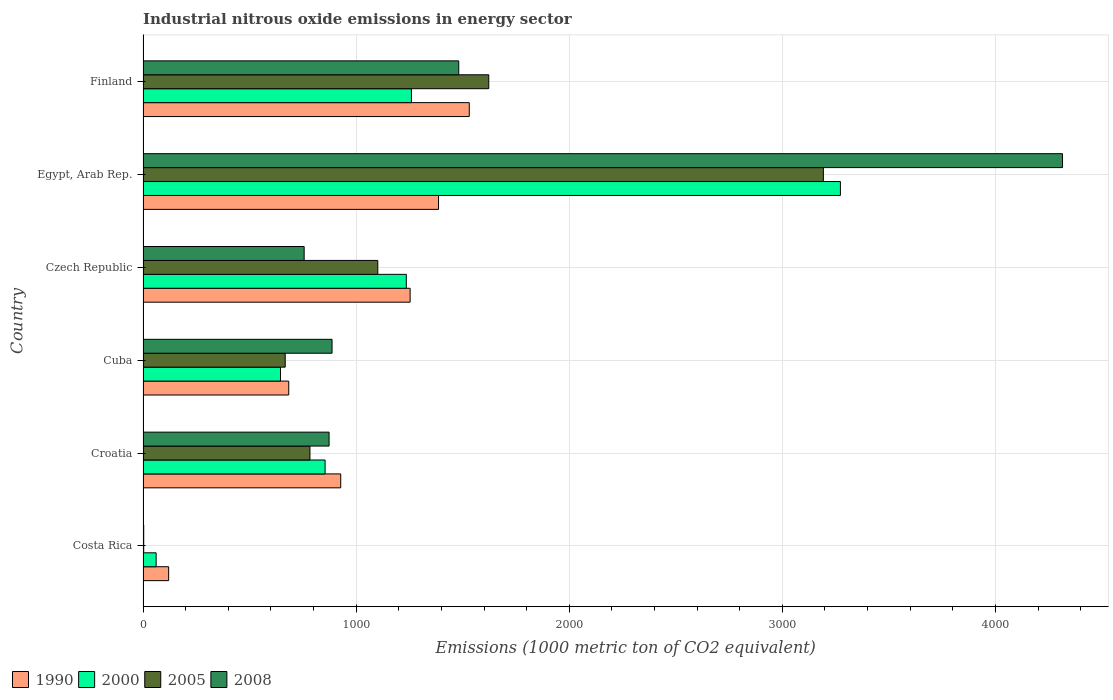Are the number of bars per tick equal to the number of legend labels?
Make the answer very short. Yes. How many bars are there on the 4th tick from the top?
Keep it short and to the point. 4. What is the label of the 3rd group of bars from the top?
Offer a terse response. Czech Republic. In how many cases, is the number of bars for a given country not equal to the number of legend labels?
Your answer should be compact. 0. What is the amount of industrial nitrous oxide emitted in 2005 in Cuba?
Your answer should be compact. 667.1. Across all countries, what is the maximum amount of industrial nitrous oxide emitted in 2008?
Ensure brevity in your answer.  4315. In which country was the amount of industrial nitrous oxide emitted in 2005 maximum?
Provide a succinct answer. Egypt, Arab Rep. In which country was the amount of industrial nitrous oxide emitted in 1990 minimum?
Make the answer very short. Costa Rica. What is the total amount of industrial nitrous oxide emitted in 2000 in the graph?
Offer a very short reply. 7328.2. What is the difference between the amount of industrial nitrous oxide emitted in 2008 in Costa Rica and that in Egypt, Arab Rep.?
Offer a terse response. -4311.9. What is the difference between the amount of industrial nitrous oxide emitted in 2008 in Czech Republic and the amount of industrial nitrous oxide emitted in 2005 in Finland?
Ensure brevity in your answer.  -866.4. What is the average amount of industrial nitrous oxide emitted in 2005 per country?
Ensure brevity in your answer.  1228.32. What is the difference between the amount of industrial nitrous oxide emitted in 2000 and amount of industrial nitrous oxide emitted in 1990 in Cuba?
Your response must be concise. -38.6. What is the ratio of the amount of industrial nitrous oxide emitted in 1990 in Czech Republic to that in Finland?
Offer a very short reply. 0.82. What is the difference between the highest and the second highest amount of industrial nitrous oxide emitted in 2000?
Your response must be concise. 2013.3. What is the difference between the highest and the lowest amount of industrial nitrous oxide emitted in 2008?
Keep it short and to the point. 4311.9. Is the sum of the amount of industrial nitrous oxide emitted in 2000 in Cuba and Finland greater than the maximum amount of industrial nitrous oxide emitted in 2005 across all countries?
Offer a very short reply. No. Is it the case that in every country, the sum of the amount of industrial nitrous oxide emitted in 1990 and amount of industrial nitrous oxide emitted in 2000 is greater than the sum of amount of industrial nitrous oxide emitted in 2005 and amount of industrial nitrous oxide emitted in 2008?
Make the answer very short. No. What does the 4th bar from the top in Finland represents?
Provide a short and direct response. 1990. How many bars are there?
Your answer should be very brief. 24. How many countries are there in the graph?
Make the answer very short. 6. What is the difference between two consecutive major ticks on the X-axis?
Provide a succinct answer. 1000. Are the values on the major ticks of X-axis written in scientific E-notation?
Offer a very short reply. No. Does the graph contain grids?
Keep it short and to the point. Yes. How are the legend labels stacked?
Make the answer very short. Horizontal. What is the title of the graph?
Offer a terse response. Industrial nitrous oxide emissions in energy sector. What is the label or title of the X-axis?
Offer a terse response. Emissions (1000 metric ton of CO2 equivalent). What is the label or title of the Y-axis?
Your answer should be very brief. Country. What is the Emissions (1000 metric ton of CO2 equivalent) of 1990 in Costa Rica?
Keep it short and to the point. 120. What is the Emissions (1000 metric ton of CO2 equivalent) in 2000 in Costa Rica?
Your response must be concise. 61.4. What is the Emissions (1000 metric ton of CO2 equivalent) of 1990 in Croatia?
Your answer should be very brief. 927.7. What is the Emissions (1000 metric ton of CO2 equivalent) in 2000 in Croatia?
Offer a terse response. 854.3. What is the Emissions (1000 metric ton of CO2 equivalent) in 2005 in Croatia?
Provide a succinct answer. 783.2. What is the Emissions (1000 metric ton of CO2 equivalent) in 2008 in Croatia?
Your response must be concise. 873. What is the Emissions (1000 metric ton of CO2 equivalent) in 1990 in Cuba?
Provide a short and direct response. 683.6. What is the Emissions (1000 metric ton of CO2 equivalent) in 2000 in Cuba?
Your response must be concise. 645. What is the Emissions (1000 metric ton of CO2 equivalent) of 2005 in Cuba?
Provide a succinct answer. 667.1. What is the Emissions (1000 metric ton of CO2 equivalent) of 2008 in Cuba?
Ensure brevity in your answer.  886.9. What is the Emissions (1000 metric ton of CO2 equivalent) of 1990 in Czech Republic?
Your answer should be very brief. 1253.3. What is the Emissions (1000 metric ton of CO2 equivalent) in 2000 in Czech Republic?
Give a very brief answer. 1235.4. What is the Emissions (1000 metric ton of CO2 equivalent) of 2005 in Czech Republic?
Your answer should be compact. 1101.5. What is the Emissions (1000 metric ton of CO2 equivalent) in 2008 in Czech Republic?
Provide a short and direct response. 756. What is the Emissions (1000 metric ton of CO2 equivalent) in 1990 in Egypt, Arab Rep.?
Provide a short and direct response. 1386.6. What is the Emissions (1000 metric ton of CO2 equivalent) in 2000 in Egypt, Arab Rep.?
Make the answer very short. 3272.7. What is the Emissions (1000 metric ton of CO2 equivalent) of 2005 in Egypt, Arab Rep.?
Your answer should be very brief. 3192.6. What is the Emissions (1000 metric ton of CO2 equivalent) of 2008 in Egypt, Arab Rep.?
Your answer should be compact. 4315. What is the Emissions (1000 metric ton of CO2 equivalent) in 1990 in Finland?
Your answer should be very brief. 1530.9. What is the Emissions (1000 metric ton of CO2 equivalent) in 2000 in Finland?
Provide a short and direct response. 1259.4. What is the Emissions (1000 metric ton of CO2 equivalent) in 2005 in Finland?
Provide a succinct answer. 1622.4. What is the Emissions (1000 metric ton of CO2 equivalent) in 2008 in Finland?
Offer a very short reply. 1481.5. Across all countries, what is the maximum Emissions (1000 metric ton of CO2 equivalent) of 1990?
Provide a short and direct response. 1530.9. Across all countries, what is the maximum Emissions (1000 metric ton of CO2 equivalent) in 2000?
Offer a very short reply. 3272.7. Across all countries, what is the maximum Emissions (1000 metric ton of CO2 equivalent) of 2005?
Your answer should be compact. 3192.6. Across all countries, what is the maximum Emissions (1000 metric ton of CO2 equivalent) in 2008?
Make the answer very short. 4315. Across all countries, what is the minimum Emissions (1000 metric ton of CO2 equivalent) in 1990?
Offer a terse response. 120. Across all countries, what is the minimum Emissions (1000 metric ton of CO2 equivalent) of 2000?
Provide a succinct answer. 61.4. Across all countries, what is the minimum Emissions (1000 metric ton of CO2 equivalent) in 2005?
Your response must be concise. 3.1. Across all countries, what is the minimum Emissions (1000 metric ton of CO2 equivalent) of 2008?
Offer a very short reply. 3.1. What is the total Emissions (1000 metric ton of CO2 equivalent) of 1990 in the graph?
Provide a short and direct response. 5902.1. What is the total Emissions (1000 metric ton of CO2 equivalent) of 2000 in the graph?
Keep it short and to the point. 7328.2. What is the total Emissions (1000 metric ton of CO2 equivalent) of 2005 in the graph?
Make the answer very short. 7369.9. What is the total Emissions (1000 metric ton of CO2 equivalent) of 2008 in the graph?
Your answer should be compact. 8315.5. What is the difference between the Emissions (1000 metric ton of CO2 equivalent) of 1990 in Costa Rica and that in Croatia?
Give a very brief answer. -807.7. What is the difference between the Emissions (1000 metric ton of CO2 equivalent) of 2000 in Costa Rica and that in Croatia?
Your answer should be very brief. -792.9. What is the difference between the Emissions (1000 metric ton of CO2 equivalent) in 2005 in Costa Rica and that in Croatia?
Your answer should be very brief. -780.1. What is the difference between the Emissions (1000 metric ton of CO2 equivalent) in 2008 in Costa Rica and that in Croatia?
Provide a succinct answer. -869.9. What is the difference between the Emissions (1000 metric ton of CO2 equivalent) in 1990 in Costa Rica and that in Cuba?
Your answer should be very brief. -563.6. What is the difference between the Emissions (1000 metric ton of CO2 equivalent) of 2000 in Costa Rica and that in Cuba?
Give a very brief answer. -583.6. What is the difference between the Emissions (1000 metric ton of CO2 equivalent) of 2005 in Costa Rica and that in Cuba?
Your response must be concise. -664. What is the difference between the Emissions (1000 metric ton of CO2 equivalent) of 2008 in Costa Rica and that in Cuba?
Keep it short and to the point. -883.8. What is the difference between the Emissions (1000 metric ton of CO2 equivalent) of 1990 in Costa Rica and that in Czech Republic?
Ensure brevity in your answer.  -1133.3. What is the difference between the Emissions (1000 metric ton of CO2 equivalent) in 2000 in Costa Rica and that in Czech Republic?
Your answer should be compact. -1174. What is the difference between the Emissions (1000 metric ton of CO2 equivalent) of 2005 in Costa Rica and that in Czech Republic?
Ensure brevity in your answer.  -1098.4. What is the difference between the Emissions (1000 metric ton of CO2 equivalent) in 2008 in Costa Rica and that in Czech Republic?
Give a very brief answer. -752.9. What is the difference between the Emissions (1000 metric ton of CO2 equivalent) of 1990 in Costa Rica and that in Egypt, Arab Rep.?
Give a very brief answer. -1266.6. What is the difference between the Emissions (1000 metric ton of CO2 equivalent) of 2000 in Costa Rica and that in Egypt, Arab Rep.?
Give a very brief answer. -3211.3. What is the difference between the Emissions (1000 metric ton of CO2 equivalent) of 2005 in Costa Rica and that in Egypt, Arab Rep.?
Give a very brief answer. -3189.5. What is the difference between the Emissions (1000 metric ton of CO2 equivalent) of 2008 in Costa Rica and that in Egypt, Arab Rep.?
Make the answer very short. -4311.9. What is the difference between the Emissions (1000 metric ton of CO2 equivalent) of 1990 in Costa Rica and that in Finland?
Offer a very short reply. -1410.9. What is the difference between the Emissions (1000 metric ton of CO2 equivalent) in 2000 in Costa Rica and that in Finland?
Give a very brief answer. -1198. What is the difference between the Emissions (1000 metric ton of CO2 equivalent) of 2005 in Costa Rica and that in Finland?
Offer a terse response. -1619.3. What is the difference between the Emissions (1000 metric ton of CO2 equivalent) of 2008 in Costa Rica and that in Finland?
Your response must be concise. -1478.4. What is the difference between the Emissions (1000 metric ton of CO2 equivalent) in 1990 in Croatia and that in Cuba?
Offer a terse response. 244.1. What is the difference between the Emissions (1000 metric ton of CO2 equivalent) of 2000 in Croatia and that in Cuba?
Offer a terse response. 209.3. What is the difference between the Emissions (1000 metric ton of CO2 equivalent) in 2005 in Croatia and that in Cuba?
Your response must be concise. 116.1. What is the difference between the Emissions (1000 metric ton of CO2 equivalent) of 2008 in Croatia and that in Cuba?
Make the answer very short. -13.9. What is the difference between the Emissions (1000 metric ton of CO2 equivalent) in 1990 in Croatia and that in Czech Republic?
Provide a succinct answer. -325.6. What is the difference between the Emissions (1000 metric ton of CO2 equivalent) of 2000 in Croatia and that in Czech Republic?
Provide a succinct answer. -381.1. What is the difference between the Emissions (1000 metric ton of CO2 equivalent) in 2005 in Croatia and that in Czech Republic?
Your answer should be compact. -318.3. What is the difference between the Emissions (1000 metric ton of CO2 equivalent) in 2008 in Croatia and that in Czech Republic?
Provide a succinct answer. 117. What is the difference between the Emissions (1000 metric ton of CO2 equivalent) of 1990 in Croatia and that in Egypt, Arab Rep.?
Offer a terse response. -458.9. What is the difference between the Emissions (1000 metric ton of CO2 equivalent) of 2000 in Croatia and that in Egypt, Arab Rep.?
Make the answer very short. -2418.4. What is the difference between the Emissions (1000 metric ton of CO2 equivalent) of 2005 in Croatia and that in Egypt, Arab Rep.?
Your answer should be compact. -2409.4. What is the difference between the Emissions (1000 metric ton of CO2 equivalent) in 2008 in Croatia and that in Egypt, Arab Rep.?
Your answer should be very brief. -3442. What is the difference between the Emissions (1000 metric ton of CO2 equivalent) in 1990 in Croatia and that in Finland?
Offer a terse response. -603.2. What is the difference between the Emissions (1000 metric ton of CO2 equivalent) in 2000 in Croatia and that in Finland?
Offer a terse response. -405.1. What is the difference between the Emissions (1000 metric ton of CO2 equivalent) of 2005 in Croatia and that in Finland?
Your response must be concise. -839.2. What is the difference between the Emissions (1000 metric ton of CO2 equivalent) of 2008 in Croatia and that in Finland?
Provide a short and direct response. -608.5. What is the difference between the Emissions (1000 metric ton of CO2 equivalent) in 1990 in Cuba and that in Czech Republic?
Your answer should be compact. -569.7. What is the difference between the Emissions (1000 metric ton of CO2 equivalent) in 2000 in Cuba and that in Czech Republic?
Your answer should be very brief. -590.4. What is the difference between the Emissions (1000 metric ton of CO2 equivalent) of 2005 in Cuba and that in Czech Republic?
Keep it short and to the point. -434.4. What is the difference between the Emissions (1000 metric ton of CO2 equivalent) in 2008 in Cuba and that in Czech Republic?
Offer a terse response. 130.9. What is the difference between the Emissions (1000 metric ton of CO2 equivalent) of 1990 in Cuba and that in Egypt, Arab Rep.?
Provide a succinct answer. -703. What is the difference between the Emissions (1000 metric ton of CO2 equivalent) of 2000 in Cuba and that in Egypt, Arab Rep.?
Offer a very short reply. -2627.7. What is the difference between the Emissions (1000 metric ton of CO2 equivalent) in 2005 in Cuba and that in Egypt, Arab Rep.?
Offer a very short reply. -2525.5. What is the difference between the Emissions (1000 metric ton of CO2 equivalent) in 2008 in Cuba and that in Egypt, Arab Rep.?
Give a very brief answer. -3428.1. What is the difference between the Emissions (1000 metric ton of CO2 equivalent) in 1990 in Cuba and that in Finland?
Provide a succinct answer. -847.3. What is the difference between the Emissions (1000 metric ton of CO2 equivalent) of 2000 in Cuba and that in Finland?
Ensure brevity in your answer.  -614.4. What is the difference between the Emissions (1000 metric ton of CO2 equivalent) of 2005 in Cuba and that in Finland?
Provide a short and direct response. -955.3. What is the difference between the Emissions (1000 metric ton of CO2 equivalent) of 2008 in Cuba and that in Finland?
Give a very brief answer. -594.6. What is the difference between the Emissions (1000 metric ton of CO2 equivalent) of 1990 in Czech Republic and that in Egypt, Arab Rep.?
Keep it short and to the point. -133.3. What is the difference between the Emissions (1000 metric ton of CO2 equivalent) of 2000 in Czech Republic and that in Egypt, Arab Rep.?
Offer a terse response. -2037.3. What is the difference between the Emissions (1000 metric ton of CO2 equivalent) of 2005 in Czech Republic and that in Egypt, Arab Rep.?
Offer a terse response. -2091.1. What is the difference between the Emissions (1000 metric ton of CO2 equivalent) in 2008 in Czech Republic and that in Egypt, Arab Rep.?
Your answer should be compact. -3559. What is the difference between the Emissions (1000 metric ton of CO2 equivalent) in 1990 in Czech Republic and that in Finland?
Provide a succinct answer. -277.6. What is the difference between the Emissions (1000 metric ton of CO2 equivalent) of 2005 in Czech Republic and that in Finland?
Offer a terse response. -520.9. What is the difference between the Emissions (1000 metric ton of CO2 equivalent) in 2008 in Czech Republic and that in Finland?
Provide a succinct answer. -725.5. What is the difference between the Emissions (1000 metric ton of CO2 equivalent) of 1990 in Egypt, Arab Rep. and that in Finland?
Offer a terse response. -144.3. What is the difference between the Emissions (1000 metric ton of CO2 equivalent) in 2000 in Egypt, Arab Rep. and that in Finland?
Provide a succinct answer. 2013.3. What is the difference between the Emissions (1000 metric ton of CO2 equivalent) of 2005 in Egypt, Arab Rep. and that in Finland?
Ensure brevity in your answer.  1570.2. What is the difference between the Emissions (1000 metric ton of CO2 equivalent) of 2008 in Egypt, Arab Rep. and that in Finland?
Give a very brief answer. 2833.5. What is the difference between the Emissions (1000 metric ton of CO2 equivalent) of 1990 in Costa Rica and the Emissions (1000 metric ton of CO2 equivalent) of 2000 in Croatia?
Keep it short and to the point. -734.3. What is the difference between the Emissions (1000 metric ton of CO2 equivalent) of 1990 in Costa Rica and the Emissions (1000 metric ton of CO2 equivalent) of 2005 in Croatia?
Keep it short and to the point. -663.2. What is the difference between the Emissions (1000 metric ton of CO2 equivalent) of 1990 in Costa Rica and the Emissions (1000 metric ton of CO2 equivalent) of 2008 in Croatia?
Offer a very short reply. -753. What is the difference between the Emissions (1000 metric ton of CO2 equivalent) of 2000 in Costa Rica and the Emissions (1000 metric ton of CO2 equivalent) of 2005 in Croatia?
Your answer should be compact. -721.8. What is the difference between the Emissions (1000 metric ton of CO2 equivalent) of 2000 in Costa Rica and the Emissions (1000 metric ton of CO2 equivalent) of 2008 in Croatia?
Provide a succinct answer. -811.6. What is the difference between the Emissions (1000 metric ton of CO2 equivalent) of 2005 in Costa Rica and the Emissions (1000 metric ton of CO2 equivalent) of 2008 in Croatia?
Provide a succinct answer. -869.9. What is the difference between the Emissions (1000 metric ton of CO2 equivalent) of 1990 in Costa Rica and the Emissions (1000 metric ton of CO2 equivalent) of 2000 in Cuba?
Provide a succinct answer. -525. What is the difference between the Emissions (1000 metric ton of CO2 equivalent) of 1990 in Costa Rica and the Emissions (1000 metric ton of CO2 equivalent) of 2005 in Cuba?
Offer a very short reply. -547.1. What is the difference between the Emissions (1000 metric ton of CO2 equivalent) in 1990 in Costa Rica and the Emissions (1000 metric ton of CO2 equivalent) in 2008 in Cuba?
Provide a succinct answer. -766.9. What is the difference between the Emissions (1000 metric ton of CO2 equivalent) of 2000 in Costa Rica and the Emissions (1000 metric ton of CO2 equivalent) of 2005 in Cuba?
Provide a succinct answer. -605.7. What is the difference between the Emissions (1000 metric ton of CO2 equivalent) of 2000 in Costa Rica and the Emissions (1000 metric ton of CO2 equivalent) of 2008 in Cuba?
Provide a succinct answer. -825.5. What is the difference between the Emissions (1000 metric ton of CO2 equivalent) of 2005 in Costa Rica and the Emissions (1000 metric ton of CO2 equivalent) of 2008 in Cuba?
Ensure brevity in your answer.  -883.8. What is the difference between the Emissions (1000 metric ton of CO2 equivalent) of 1990 in Costa Rica and the Emissions (1000 metric ton of CO2 equivalent) of 2000 in Czech Republic?
Provide a short and direct response. -1115.4. What is the difference between the Emissions (1000 metric ton of CO2 equivalent) in 1990 in Costa Rica and the Emissions (1000 metric ton of CO2 equivalent) in 2005 in Czech Republic?
Your answer should be very brief. -981.5. What is the difference between the Emissions (1000 metric ton of CO2 equivalent) in 1990 in Costa Rica and the Emissions (1000 metric ton of CO2 equivalent) in 2008 in Czech Republic?
Make the answer very short. -636. What is the difference between the Emissions (1000 metric ton of CO2 equivalent) in 2000 in Costa Rica and the Emissions (1000 metric ton of CO2 equivalent) in 2005 in Czech Republic?
Make the answer very short. -1040.1. What is the difference between the Emissions (1000 metric ton of CO2 equivalent) of 2000 in Costa Rica and the Emissions (1000 metric ton of CO2 equivalent) of 2008 in Czech Republic?
Your answer should be very brief. -694.6. What is the difference between the Emissions (1000 metric ton of CO2 equivalent) of 2005 in Costa Rica and the Emissions (1000 metric ton of CO2 equivalent) of 2008 in Czech Republic?
Provide a succinct answer. -752.9. What is the difference between the Emissions (1000 metric ton of CO2 equivalent) in 1990 in Costa Rica and the Emissions (1000 metric ton of CO2 equivalent) in 2000 in Egypt, Arab Rep.?
Give a very brief answer. -3152.7. What is the difference between the Emissions (1000 metric ton of CO2 equivalent) in 1990 in Costa Rica and the Emissions (1000 metric ton of CO2 equivalent) in 2005 in Egypt, Arab Rep.?
Your response must be concise. -3072.6. What is the difference between the Emissions (1000 metric ton of CO2 equivalent) of 1990 in Costa Rica and the Emissions (1000 metric ton of CO2 equivalent) of 2008 in Egypt, Arab Rep.?
Offer a very short reply. -4195. What is the difference between the Emissions (1000 metric ton of CO2 equivalent) of 2000 in Costa Rica and the Emissions (1000 metric ton of CO2 equivalent) of 2005 in Egypt, Arab Rep.?
Give a very brief answer. -3131.2. What is the difference between the Emissions (1000 metric ton of CO2 equivalent) in 2000 in Costa Rica and the Emissions (1000 metric ton of CO2 equivalent) in 2008 in Egypt, Arab Rep.?
Offer a terse response. -4253.6. What is the difference between the Emissions (1000 metric ton of CO2 equivalent) in 2005 in Costa Rica and the Emissions (1000 metric ton of CO2 equivalent) in 2008 in Egypt, Arab Rep.?
Offer a very short reply. -4311.9. What is the difference between the Emissions (1000 metric ton of CO2 equivalent) in 1990 in Costa Rica and the Emissions (1000 metric ton of CO2 equivalent) in 2000 in Finland?
Make the answer very short. -1139.4. What is the difference between the Emissions (1000 metric ton of CO2 equivalent) of 1990 in Costa Rica and the Emissions (1000 metric ton of CO2 equivalent) of 2005 in Finland?
Your response must be concise. -1502.4. What is the difference between the Emissions (1000 metric ton of CO2 equivalent) of 1990 in Costa Rica and the Emissions (1000 metric ton of CO2 equivalent) of 2008 in Finland?
Provide a succinct answer. -1361.5. What is the difference between the Emissions (1000 metric ton of CO2 equivalent) of 2000 in Costa Rica and the Emissions (1000 metric ton of CO2 equivalent) of 2005 in Finland?
Provide a succinct answer. -1561. What is the difference between the Emissions (1000 metric ton of CO2 equivalent) in 2000 in Costa Rica and the Emissions (1000 metric ton of CO2 equivalent) in 2008 in Finland?
Offer a very short reply. -1420.1. What is the difference between the Emissions (1000 metric ton of CO2 equivalent) of 2005 in Costa Rica and the Emissions (1000 metric ton of CO2 equivalent) of 2008 in Finland?
Your answer should be compact. -1478.4. What is the difference between the Emissions (1000 metric ton of CO2 equivalent) of 1990 in Croatia and the Emissions (1000 metric ton of CO2 equivalent) of 2000 in Cuba?
Offer a terse response. 282.7. What is the difference between the Emissions (1000 metric ton of CO2 equivalent) of 1990 in Croatia and the Emissions (1000 metric ton of CO2 equivalent) of 2005 in Cuba?
Your answer should be very brief. 260.6. What is the difference between the Emissions (1000 metric ton of CO2 equivalent) in 1990 in Croatia and the Emissions (1000 metric ton of CO2 equivalent) in 2008 in Cuba?
Your answer should be compact. 40.8. What is the difference between the Emissions (1000 metric ton of CO2 equivalent) in 2000 in Croatia and the Emissions (1000 metric ton of CO2 equivalent) in 2005 in Cuba?
Provide a succinct answer. 187.2. What is the difference between the Emissions (1000 metric ton of CO2 equivalent) in 2000 in Croatia and the Emissions (1000 metric ton of CO2 equivalent) in 2008 in Cuba?
Offer a very short reply. -32.6. What is the difference between the Emissions (1000 metric ton of CO2 equivalent) in 2005 in Croatia and the Emissions (1000 metric ton of CO2 equivalent) in 2008 in Cuba?
Make the answer very short. -103.7. What is the difference between the Emissions (1000 metric ton of CO2 equivalent) in 1990 in Croatia and the Emissions (1000 metric ton of CO2 equivalent) in 2000 in Czech Republic?
Provide a short and direct response. -307.7. What is the difference between the Emissions (1000 metric ton of CO2 equivalent) of 1990 in Croatia and the Emissions (1000 metric ton of CO2 equivalent) of 2005 in Czech Republic?
Ensure brevity in your answer.  -173.8. What is the difference between the Emissions (1000 metric ton of CO2 equivalent) of 1990 in Croatia and the Emissions (1000 metric ton of CO2 equivalent) of 2008 in Czech Republic?
Provide a succinct answer. 171.7. What is the difference between the Emissions (1000 metric ton of CO2 equivalent) of 2000 in Croatia and the Emissions (1000 metric ton of CO2 equivalent) of 2005 in Czech Republic?
Keep it short and to the point. -247.2. What is the difference between the Emissions (1000 metric ton of CO2 equivalent) of 2000 in Croatia and the Emissions (1000 metric ton of CO2 equivalent) of 2008 in Czech Republic?
Ensure brevity in your answer.  98.3. What is the difference between the Emissions (1000 metric ton of CO2 equivalent) in 2005 in Croatia and the Emissions (1000 metric ton of CO2 equivalent) in 2008 in Czech Republic?
Your answer should be very brief. 27.2. What is the difference between the Emissions (1000 metric ton of CO2 equivalent) of 1990 in Croatia and the Emissions (1000 metric ton of CO2 equivalent) of 2000 in Egypt, Arab Rep.?
Offer a terse response. -2345. What is the difference between the Emissions (1000 metric ton of CO2 equivalent) of 1990 in Croatia and the Emissions (1000 metric ton of CO2 equivalent) of 2005 in Egypt, Arab Rep.?
Give a very brief answer. -2264.9. What is the difference between the Emissions (1000 metric ton of CO2 equivalent) in 1990 in Croatia and the Emissions (1000 metric ton of CO2 equivalent) in 2008 in Egypt, Arab Rep.?
Ensure brevity in your answer.  -3387.3. What is the difference between the Emissions (1000 metric ton of CO2 equivalent) of 2000 in Croatia and the Emissions (1000 metric ton of CO2 equivalent) of 2005 in Egypt, Arab Rep.?
Give a very brief answer. -2338.3. What is the difference between the Emissions (1000 metric ton of CO2 equivalent) in 2000 in Croatia and the Emissions (1000 metric ton of CO2 equivalent) in 2008 in Egypt, Arab Rep.?
Your answer should be compact. -3460.7. What is the difference between the Emissions (1000 metric ton of CO2 equivalent) in 2005 in Croatia and the Emissions (1000 metric ton of CO2 equivalent) in 2008 in Egypt, Arab Rep.?
Your answer should be very brief. -3531.8. What is the difference between the Emissions (1000 metric ton of CO2 equivalent) of 1990 in Croatia and the Emissions (1000 metric ton of CO2 equivalent) of 2000 in Finland?
Your answer should be very brief. -331.7. What is the difference between the Emissions (1000 metric ton of CO2 equivalent) in 1990 in Croatia and the Emissions (1000 metric ton of CO2 equivalent) in 2005 in Finland?
Make the answer very short. -694.7. What is the difference between the Emissions (1000 metric ton of CO2 equivalent) in 1990 in Croatia and the Emissions (1000 metric ton of CO2 equivalent) in 2008 in Finland?
Your answer should be very brief. -553.8. What is the difference between the Emissions (1000 metric ton of CO2 equivalent) of 2000 in Croatia and the Emissions (1000 metric ton of CO2 equivalent) of 2005 in Finland?
Your answer should be very brief. -768.1. What is the difference between the Emissions (1000 metric ton of CO2 equivalent) of 2000 in Croatia and the Emissions (1000 metric ton of CO2 equivalent) of 2008 in Finland?
Make the answer very short. -627.2. What is the difference between the Emissions (1000 metric ton of CO2 equivalent) of 2005 in Croatia and the Emissions (1000 metric ton of CO2 equivalent) of 2008 in Finland?
Keep it short and to the point. -698.3. What is the difference between the Emissions (1000 metric ton of CO2 equivalent) of 1990 in Cuba and the Emissions (1000 metric ton of CO2 equivalent) of 2000 in Czech Republic?
Make the answer very short. -551.8. What is the difference between the Emissions (1000 metric ton of CO2 equivalent) of 1990 in Cuba and the Emissions (1000 metric ton of CO2 equivalent) of 2005 in Czech Republic?
Your response must be concise. -417.9. What is the difference between the Emissions (1000 metric ton of CO2 equivalent) in 1990 in Cuba and the Emissions (1000 metric ton of CO2 equivalent) in 2008 in Czech Republic?
Offer a very short reply. -72.4. What is the difference between the Emissions (1000 metric ton of CO2 equivalent) of 2000 in Cuba and the Emissions (1000 metric ton of CO2 equivalent) of 2005 in Czech Republic?
Provide a succinct answer. -456.5. What is the difference between the Emissions (1000 metric ton of CO2 equivalent) of 2000 in Cuba and the Emissions (1000 metric ton of CO2 equivalent) of 2008 in Czech Republic?
Your answer should be very brief. -111. What is the difference between the Emissions (1000 metric ton of CO2 equivalent) in 2005 in Cuba and the Emissions (1000 metric ton of CO2 equivalent) in 2008 in Czech Republic?
Offer a terse response. -88.9. What is the difference between the Emissions (1000 metric ton of CO2 equivalent) of 1990 in Cuba and the Emissions (1000 metric ton of CO2 equivalent) of 2000 in Egypt, Arab Rep.?
Your answer should be compact. -2589.1. What is the difference between the Emissions (1000 metric ton of CO2 equivalent) of 1990 in Cuba and the Emissions (1000 metric ton of CO2 equivalent) of 2005 in Egypt, Arab Rep.?
Keep it short and to the point. -2509. What is the difference between the Emissions (1000 metric ton of CO2 equivalent) of 1990 in Cuba and the Emissions (1000 metric ton of CO2 equivalent) of 2008 in Egypt, Arab Rep.?
Your answer should be compact. -3631.4. What is the difference between the Emissions (1000 metric ton of CO2 equivalent) of 2000 in Cuba and the Emissions (1000 metric ton of CO2 equivalent) of 2005 in Egypt, Arab Rep.?
Make the answer very short. -2547.6. What is the difference between the Emissions (1000 metric ton of CO2 equivalent) of 2000 in Cuba and the Emissions (1000 metric ton of CO2 equivalent) of 2008 in Egypt, Arab Rep.?
Keep it short and to the point. -3670. What is the difference between the Emissions (1000 metric ton of CO2 equivalent) of 2005 in Cuba and the Emissions (1000 metric ton of CO2 equivalent) of 2008 in Egypt, Arab Rep.?
Provide a succinct answer. -3647.9. What is the difference between the Emissions (1000 metric ton of CO2 equivalent) in 1990 in Cuba and the Emissions (1000 metric ton of CO2 equivalent) in 2000 in Finland?
Your answer should be very brief. -575.8. What is the difference between the Emissions (1000 metric ton of CO2 equivalent) of 1990 in Cuba and the Emissions (1000 metric ton of CO2 equivalent) of 2005 in Finland?
Give a very brief answer. -938.8. What is the difference between the Emissions (1000 metric ton of CO2 equivalent) in 1990 in Cuba and the Emissions (1000 metric ton of CO2 equivalent) in 2008 in Finland?
Ensure brevity in your answer.  -797.9. What is the difference between the Emissions (1000 metric ton of CO2 equivalent) in 2000 in Cuba and the Emissions (1000 metric ton of CO2 equivalent) in 2005 in Finland?
Make the answer very short. -977.4. What is the difference between the Emissions (1000 metric ton of CO2 equivalent) in 2000 in Cuba and the Emissions (1000 metric ton of CO2 equivalent) in 2008 in Finland?
Keep it short and to the point. -836.5. What is the difference between the Emissions (1000 metric ton of CO2 equivalent) of 2005 in Cuba and the Emissions (1000 metric ton of CO2 equivalent) of 2008 in Finland?
Your answer should be very brief. -814.4. What is the difference between the Emissions (1000 metric ton of CO2 equivalent) in 1990 in Czech Republic and the Emissions (1000 metric ton of CO2 equivalent) in 2000 in Egypt, Arab Rep.?
Offer a very short reply. -2019.4. What is the difference between the Emissions (1000 metric ton of CO2 equivalent) of 1990 in Czech Republic and the Emissions (1000 metric ton of CO2 equivalent) of 2005 in Egypt, Arab Rep.?
Ensure brevity in your answer.  -1939.3. What is the difference between the Emissions (1000 metric ton of CO2 equivalent) of 1990 in Czech Republic and the Emissions (1000 metric ton of CO2 equivalent) of 2008 in Egypt, Arab Rep.?
Your response must be concise. -3061.7. What is the difference between the Emissions (1000 metric ton of CO2 equivalent) of 2000 in Czech Republic and the Emissions (1000 metric ton of CO2 equivalent) of 2005 in Egypt, Arab Rep.?
Your response must be concise. -1957.2. What is the difference between the Emissions (1000 metric ton of CO2 equivalent) of 2000 in Czech Republic and the Emissions (1000 metric ton of CO2 equivalent) of 2008 in Egypt, Arab Rep.?
Your response must be concise. -3079.6. What is the difference between the Emissions (1000 metric ton of CO2 equivalent) in 2005 in Czech Republic and the Emissions (1000 metric ton of CO2 equivalent) in 2008 in Egypt, Arab Rep.?
Your answer should be very brief. -3213.5. What is the difference between the Emissions (1000 metric ton of CO2 equivalent) in 1990 in Czech Republic and the Emissions (1000 metric ton of CO2 equivalent) in 2005 in Finland?
Your answer should be compact. -369.1. What is the difference between the Emissions (1000 metric ton of CO2 equivalent) of 1990 in Czech Republic and the Emissions (1000 metric ton of CO2 equivalent) of 2008 in Finland?
Make the answer very short. -228.2. What is the difference between the Emissions (1000 metric ton of CO2 equivalent) in 2000 in Czech Republic and the Emissions (1000 metric ton of CO2 equivalent) in 2005 in Finland?
Make the answer very short. -387. What is the difference between the Emissions (1000 metric ton of CO2 equivalent) in 2000 in Czech Republic and the Emissions (1000 metric ton of CO2 equivalent) in 2008 in Finland?
Provide a short and direct response. -246.1. What is the difference between the Emissions (1000 metric ton of CO2 equivalent) in 2005 in Czech Republic and the Emissions (1000 metric ton of CO2 equivalent) in 2008 in Finland?
Keep it short and to the point. -380. What is the difference between the Emissions (1000 metric ton of CO2 equivalent) of 1990 in Egypt, Arab Rep. and the Emissions (1000 metric ton of CO2 equivalent) of 2000 in Finland?
Offer a very short reply. 127.2. What is the difference between the Emissions (1000 metric ton of CO2 equivalent) of 1990 in Egypt, Arab Rep. and the Emissions (1000 metric ton of CO2 equivalent) of 2005 in Finland?
Offer a very short reply. -235.8. What is the difference between the Emissions (1000 metric ton of CO2 equivalent) of 1990 in Egypt, Arab Rep. and the Emissions (1000 metric ton of CO2 equivalent) of 2008 in Finland?
Offer a very short reply. -94.9. What is the difference between the Emissions (1000 metric ton of CO2 equivalent) of 2000 in Egypt, Arab Rep. and the Emissions (1000 metric ton of CO2 equivalent) of 2005 in Finland?
Ensure brevity in your answer.  1650.3. What is the difference between the Emissions (1000 metric ton of CO2 equivalent) in 2000 in Egypt, Arab Rep. and the Emissions (1000 metric ton of CO2 equivalent) in 2008 in Finland?
Keep it short and to the point. 1791.2. What is the difference between the Emissions (1000 metric ton of CO2 equivalent) of 2005 in Egypt, Arab Rep. and the Emissions (1000 metric ton of CO2 equivalent) of 2008 in Finland?
Your answer should be compact. 1711.1. What is the average Emissions (1000 metric ton of CO2 equivalent) of 1990 per country?
Provide a succinct answer. 983.68. What is the average Emissions (1000 metric ton of CO2 equivalent) in 2000 per country?
Offer a terse response. 1221.37. What is the average Emissions (1000 metric ton of CO2 equivalent) in 2005 per country?
Your answer should be very brief. 1228.32. What is the average Emissions (1000 metric ton of CO2 equivalent) of 2008 per country?
Provide a short and direct response. 1385.92. What is the difference between the Emissions (1000 metric ton of CO2 equivalent) of 1990 and Emissions (1000 metric ton of CO2 equivalent) of 2000 in Costa Rica?
Ensure brevity in your answer.  58.6. What is the difference between the Emissions (1000 metric ton of CO2 equivalent) of 1990 and Emissions (1000 metric ton of CO2 equivalent) of 2005 in Costa Rica?
Ensure brevity in your answer.  116.9. What is the difference between the Emissions (1000 metric ton of CO2 equivalent) in 1990 and Emissions (1000 metric ton of CO2 equivalent) in 2008 in Costa Rica?
Your response must be concise. 116.9. What is the difference between the Emissions (1000 metric ton of CO2 equivalent) of 2000 and Emissions (1000 metric ton of CO2 equivalent) of 2005 in Costa Rica?
Your response must be concise. 58.3. What is the difference between the Emissions (1000 metric ton of CO2 equivalent) of 2000 and Emissions (1000 metric ton of CO2 equivalent) of 2008 in Costa Rica?
Your answer should be very brief. 58.3. What is the difference between the Emissions (1000 metric ton of CO2 equivalent) in 2005 and Emissions (1000 metric ton of CO2 equivalent) in 2008 in Costa Rica?
Your answer should be very brief. 0. What is the difference between the Emissions (1000 metric ton of CO2 equivalent) of 1990 and Emissions (1000 metric ton of CO2 equivalent) of 2000 in Croatia?
Provide a succinct answer. 73.4. What is the difference between the Emissions (1000 metric ton of CO2 equivalent) in 1990 and Emissions (1000 metric ton of CO2 equivalent) in 2005 in Croatia?
Provide a short and direct response. 144.5. What is the difference between the Emissions (1000 metric ton of CO2 equivalent) of 1990 and Emissions (1000 metric ton of CO2 equivalent) of 2008 in Croatia?
Offer a very short reply. 54.7. What is the difference between the Emissions (1000 metric ton of CO2 equivalent) of 2000 and Emissions (1000 metric ton of CO2 equivalent) of 2005 in Croatia?
Your response must be concise. 71.1. What is the difference between the Emissions (1000 metric ton of CO2 equivalent) of 2000 and Emissions (1000 metric ton of CO2 equivalent) of 2008 in Croatia?
Provide a succinct answer. -18.7. What is the difference between the Emissions (1000 metric ton of CO2 equivalent) of 2005 and Emissions (1000 metric ton of CO2 equivalent) of 2008 in Croatia?
Your answer should be compact. -89.8. What is the difference between the Emissions (1000 metric ton of CO2 equivalent) in 1990 and Emissions (1000 metric ton of CO2 equivalent) in 2000 in Cuba?
Give a very brief answer. 38.6. What is the difference between the Emissions (1000 metric ton of CO2 equivalent) of 1990 and Emissions (1000 metric ton of CO2 equivalent) of 2005 in Cuba?
Give a very brief answer. 16.5. What is the difference between the Emissions (1000 metric ton of CO2 equivalent) in 1990 and Emissions (1000 metric ton of CO2 equivalent) in 2008 in Cuba?
Ensure brevity in your answer.  -203.3. What is the difference between the Emissions (1000 metric ton of CO2 equivalent) in 2000 and Emissions (1000 metric ton of CO2 equivalent) in 2005 in Cuba?
Make the answer very short. -22.1. What is the difference between the Emissions (1000 metric ton of CO2 equivalent) in 2000 and Emissions (1000 metric ton of CO2 equivalent) in 2008 in Cuba?
Provide a succinct answer. -241.9. What is the difference between the Emissions (1000 metric ton of CO2 equivalent) in 2005 and Emissions (1000 metric ton of CO2 equivalent) in 2008 in Cuba?
Offer a terse response. -219.8. What is the difference between the Emissions (1000 metric ton of CO2 equivalent) in 1990 and Emissions (1000 metric ton of CO2 equivalent) in 2000 in Czech Republic?
Ensure brevity in your answer.  17.9. What is the difference between the Emissions (1000 metric ton of CO2 equivalent) of 1990 and Emissions (1000 metric ton of CO2 equivalent) of 2005 in Czech Republic?
Provide a short and direct response. 151.8. What is the difference between the Emissions (1000 metric ton of CO2 equivalent) in 1990 and Emissions (1000 metric ton of CO2 equivalent) in 2008 in Czech Republic?
Give a very brief answer. 497.3. What is the difference between the Emissions (1000 metric ton of CO2 equivalent) of 2000 and Emissions (1000 metric ton of CO2 equivalent) of 2005 in Czech Republic?
Keep it short and to the point. 133.9. What is the difference between the Emissions (1000 metric ton of CO2 equivalent) of 2000 and Emissions (1000 metric ton of CO2 equivalent) of 2008 in Czech Republic?
Provide a succinct answer. 479.4. What is the difference between the Emissions (1000 metric ton of CO2 equivalent) of 2005 and Emissions (1000 metric ton of CO2 equivalent) of 2008 in Czech Republic?
Give a very brief answer. 345.5. What is the difference between the Emissions (1000 metric ton of CO2 equivalent) of 1990 and Emissions (1000 metric ton of CO2 equivalent) of 2000 in Egypt, Arab Rep.?
Offer a very short reply. -1886.1. What is the difference between the Emissions (1000 metric ton of CO2 equivalent) of 1990 and Emissions (1000 metric ton of CO2 equivalent) of 2005 in Egypt, Arab Rep.?
Give a very brief answer. -1806. What is the difference between the Emissions (1000 metric ton of CO2 equivalent) of 1990 and Emissions (1000 metric ton of CO2 equivalent) of 2008 in Egypt, Arab Rep.?
Your answer should be very brief. -2928.4. What is the difference between the Emissions (1000 metric ton of CO2 equivalent) of 2000 and Emissions (1000 metric ton of CO2 equivalent) of 2005 in Egypt, Arab Rep.?
Provide a short and direct response. 80.1. What is the difference between the Emissions (1000 metric ton of CO2 equivalent) in 2000 and Emissions (1000 metric ton of CO2 equivalent) in 2008 in Egypt, Arab Rep.?
Provide a short and direct response. -1042.3. What is the difference between the Emissions (1000 metric ton of CO2 equivalent) in 2005 and Emissions (1000 metric ton of CO2 equivalent) in 2008 in Egypt, Arab Rep.?
Keep it short and to the point. -1122.4. What is the difference between the Emissions (1000 metric ton of CO2 equivalent) of 1990 and Emissions (1000 metric ton of CO2 equivalent) of 2000 in Finland?
Your answer should be compact. 271.5. What is the difference between the Emissions (1000 metric ton of CO2 equivalent) in 1990 and Emissions (1000 metric ton of CO2 equivalent) in 2005 in Finland?
Offer a very short reply. -91.5. What is the difference between the Emissions (1000 metric ton of CO2 equivalent) of 1990 and Emissions (1000 metric ton of CO2 equivalent) of 2008 in Finland?
Offer a very short reply. 49.4. What is the difference between the Emissions (1000 metric ton of CO2 equivalent) in 2000 and Emissions (1000 metric ton of CO2 equivalent) in 2005 in Finland?
Provide a short and direct response. -363. What is the difference between the Emissions (1000 metric ton of CO2 equivalent) in 2000 and Emissions (1000 metric ton of CO2 equivalent) in 2008 in Finland?
Ensure brevity in your answer.  -222.1. What is the difference between the Emissions (1000 metric ton of CO2 equivalent) of 2005 and Emissions (1000 metric ton of CO2 equivalent) of 2008 in Finland?
Your answer should be very brief. 140.9. What is the ratio of the Emissions (1000 metric ton of CO2 equivalent) of 1990 in Costa Rica to that in Croatia?
Your response must be concise. 0.13. What is the ratio of the Emissions (1000 metric ton of CO2 equivalent) in 2000 in Costa Rica to that in Croatia?
Provide a short and direct response. 0.07. What is the ratio of the Emissions (1000 metric ton of CO2 equivalent) of 2005 in Costa Rica to that in Croatia?
Make the answer very short. 0. What is the ratio of the Emissions (1000 metric ton of CO2 equivalent) of 2008 in Costa Rica to that in Croatia?
Offer a very short reply. 0. What is the ratio of the Emissions (1000 metric ton of CO2 equivalent) of 1990 in Costa Rica to that in Cuba?
Ensure brevity in your answer.  0.18. What is the ratio of the Emissions (1000 metric ton of CO2 equivalent) in 2000 in Costa Rica to that in Cuba?
Make the answer very short. 0.1. What is the ratio of the Emissions (1000 metric ton of CO2 equivalent) of 2005 in Costa Rica to that in Cuba?
Your answer should be very brief. 0. What is the ratio of the Emissions (1000 metric ton of CO2 equivalent) in 2008 in Costa Rica to that in Cuba?
Your answer should be compact. 0. What is the ratio of the Emissions (1000 metric ton of CO2 equivalent) in 1990 in Costa Rica to that in Czech Republic?
Your response must be concise. 0.1. What is the ratio of the Emissions (1000 metric ton of CO2 equivalent) in 2000 in Costa Rica to that in Czech Republic?
Offer a very short reply. 0.05. What is the ratio of the Emissions (1000 metric ton of CO2 equivalent) in 2005 in Costa Rica to that in Czech Republic?
Give a very brief answer. 0. What is the ratio of the Emissions (1000 metric ton of CO2 equivalent) of 2008 in Costa Rica to that in Czech Republic?
Keep it short and to the point. 0. What is the ratio of the Emissions (1000 metric ton of CO2 equivalent) in 1990 in Costa Rica to that in Egypt, Arab Rep.?
Give a very brief answer. 0.09. What is the ratio of the Emissions (1000 metric ton of CO2 equivalent) of 2000 in Costa Rica to that in Egypt, Arab Rep.?
Your answer should be very brief. 0.02. What is the ratio of the Emissions (1000 metric ton of CO2 equivalent) in 2008 in Costa Rica to that in Egypt, Arab Rep.?
Offer a very short reply. 0. What is the ratio of the Emissions (1000 metric ton of CO2 equivalent) in 1990 in Costa Rica to that in Finland?
Keep it short and to the point. 0.08. What is the ratio of the Emissions (1000 metric ton of CO2 equivalent) of 2000 in Costa Rica to that in Finland?
Your response must be concise. 0.05. What is the ratio of the Emissions (1000 metric ton of CO2 equivalent) in 2005 in Costa Rica to that in Finland?
Ensure brevity in your answer.  0. What is the ratio of the Emissions (1000 metric ton of CO2 equivalent) of 2008 in Costa Rica to that in Finland?
Provide a succinct answer. 0. What is the ratio of the Emissions (1000 metric ton of CO2 equivalent) in 1990 in Croatia to that in Cuba?
Your answer should be compact. 1.36. What is the ratio of the Emissions (1000 metric ton of CO2 equivalent) of 2000 in Croatia to that in Cuba?
Your answer should be very brief. 1.32. What is the ratio of the Emissions (1000 metric ton of CO2 equivalent) of 2005 in Croatia to that in Cuba?
Provide a succinct answer. 1.17. What is the ratio of the Emissions (1000 metric ton of CO2 equivalent) of 2008 in Croatia to that in Cuba?
Your answer should be very brief. 0.98. What is the ratio of the Emissions (1000 metric ton of CO2 equivalent) of 1990 in Croatia to that in Czech Republic?
Your answer should be compact. 0.74. What is the ratio of the Emissions (1000 metric ton of CO2 equivalent) of 2000 in Croatia to that in Czech Republic?
Make the answer very short. 0.69. What is the ratio of the Emissions (1000 metric ton of CO2 equivalent) in 2005 in Croatia to that in Czech Republic?
Provide a succinct answer. 0.71. What is the ratio of the Emissions (1000 metric ton of CO2 equivalent) of 2008 in Croatia to that in Czech Republic?
Your answer should be very brief. 1.15. What is the ratio of the Emissions (1000 metric ton of CO2 equivalent) of 1990 in Croatia to that in Egypt, Arab Rep.?
Offer a terse response. 0.67. What is the ratio of the Emissions (1000 metric ton of CO2 equivalent) of 2000 in Croatia to that in Egypt, Arab Rep.?
Provide a short and direct response. 0.26. What is the ratio of the Emissions (1000 metric ton of CO2 equivalent) in 2005 in Croatia to that in Egypt, Arab Rep.?
Your response must be concise. 0.25. What is the ratio of the Emissions (1000 metric ton of CO2 equivalent) of 2008 in Croatia to that in Egypt, Arab Rep.?
Provide a short and direct response. 0.2. What is the ratio of the Emissions (1000 metric ton of CO2 equivalent) of 1990 in Croatia to that in Finland?
Ensure brevity in your answer.  0.61. What is the ratio of the Emissions (1000 metric ton of CO2 equivalent) in 2000 in Croatia to that in Finland?
Keep it short and to the point. 0.68. What is the ratio of the Emissions (1000 metric ton of CO2 equivalent) in 2005 in Croatia to that in Finland?
Make the answer very short. 0.48. What is the ratio of the Emissions (1000 metric ton of CO2 equivalent) in 2008 in Croatia to that in Finland?
Keep it short and to the point. 0.59. What is the ratio of the Emissions (1000 metric ton of CO2 equivalent) of 1990 in Cuba to that in Czech Republic?
Ensure brevity in your answer.  0.55. What is the ratio of the Emissions (1000 metric ton of CO2 equivalent) of 2000 in Cuba to that in Czech Republic?
Offer a very short reply. 0.52. What is the ratio of the Emissions (1000 metric ton of CO2 equivalent) in 2005 in Cuba to that in Czech Republic?
Your answer should be very brief. 0.61. What is the ratio of the Emissions (1000 metric ton of CO2 equivalent) in 2008 in Cuba to that in Czech Republic?
Offer a very short reply. 1.17. What is the ratio of the Emissions (1000 metric ton of CO2 equivalent) of 1990 in Cuba to that in Egypt, Arab Rep.?
Your answer should be compact. 0.49. What is the ratio of the Emissions (1000 metric ton of CO2 equivalent) of 2000 in Cuba to that in Egypt, Arab Rep.?
Your answer should be very brief. 0.2. What is the ratio of the Emissions (1000 metric ton of CO2 equivalent) of 2005 in Cuba to that in Egypt, Arab Rep.?
Your answer should be compact. 0.21. What is the ratio of the Emissions (1000 metric ton of CO2 equivalent) of 2008 in Cuba to that in Egypt, Arab Rep.?
Give a very brief answer. 0.21. What is the ratio of the Emissions (1000 metric ton of CO2 equivalent) of 1990 in Cuba to that in Finland?
Offer a very short reply. 0.45. What is the ratio of the Emissions (1000 metric ton of CO2 equivalent) of 2000 in Cuba to that in Finland?
Keep it short and to the point. 0.51. What is the ratio of the Emissions (1000 metric ton of CO2 equivalent) of 2005 in Cuba to that in Finland?
Your answer should be compact. 0.41. What is the ratio of the Emissions (1000 metric ton of CO2 equivalent) of 2008 in Cuba to that in Finland?
Provide a short and direct response. 0.6. What is the ratio of the Emissions (1000 metric ton of CO2 equivalent) of 1990 in Czech Republic to that in Egypt, Arab Rep.?
Provide a succinct answer. 0.9. What is the ratio of the Emissions (1000 metric ton of CO2 equivalent) of 2000 in Czech Republic to that in Egypt, Arab Rep.?
Your answer should be very brief. 0.38. What is the ratio of the Emissions (1000 metric ton of CO2 equivalent) in 2005 in Czech Republic to that in Egypt, Arab Rep.?
Your answer should be very brief. 0.34. What is the ratio of the Emissions (1000 metric ton of CO2 equivalent) of 2008 in Czech Republic to that in Egypt, Arab Rep.?
Keep it short and to the point. 0.18. What is the ratio of the Emissions (1000 metric ton of CO2 equivalent) of 1990 in Czech Republic to that in Finland?
Offer a terse response. 0.82. What is the ratio of the Emissions (1000 metric ton of CO2 equivalent) of 2000 in Czech Republic to that in Finland?
Provide a short and direct response. 0.98. What is the ratio of the Emissions (1000 metric ton of CO2 equivalent) of 2005 in Czech Republic to that in Finland?
Offer a terse response. 0.68. What is the ratio of the Emissions (1000 metric ton of CO2 equivalent) of 2008 in Czech Republic to that in Finland?
Ensure brevity in your answer.  0.51. What is the ratio of the Emissions (1000 metric ton of CO2 equivalent) in 1990 in Egypt, Arab Rep. to that in Finland?
Your answer should be compact. 0.91. What is the ratio of the Emissions (1000 metric ton of CO2 equivalent) in 2000 in Egypt, Arab Rep. to that in Finland?
Give a very brief answer. 2.6. What is the ratio of the Emissions (1000 metric ton of CO2 equivalent) in 2005 in Egypt, Arab Rep. to that in Finland?
Offer a very short reply. 1.97. What is the ratio of the Emissions (1000 metric ton of CO2 equivalent) in 2008 in Egypt, Arab Rep. to that in Finland?
Your answer should be compact. 2.91. What is the difference between the highest and the second highest Emissions (1000 metric ton of CO2 equivalent) of 1990?
Make the answer very short. 144.3. What is the difference between the highest and the second highest Emissions (1000 metric ton of CO2 equivalent) of 2000?
Provide a short and direct response. 2013.3. What is the difference between the highest and the second highest Emissions (1000 metric ton of CO2 equivalent) of 2005?
Make the answer very short. 1570.2. What is the difference between the highest and the second highest Emissions (1000 metric ton of CO2 equivalent) of 2008?
Provide a succinct answer. 2833.5. What is the difference between the highest and the lowest Emissions (1000 metric ton of CO2 equivalent) in 1990?
Your answer should be very brief. 1410.9. What is the difference between the highest and the lowest Emissions (1000 metric ton of CO2 equivalent) in 2000?
Offer a very short reply. 3211.3. What is the difference between the highest and the lowest Emissions (1000 metric ton of CO2 equivalent) in 2005?
Offer a terse response. 3189.5. What is the difference between the highest and the lowest Emissions (1000 metric ton of CO2 equivalent) of 2008?
Your answer should be compact. 4311.9. 